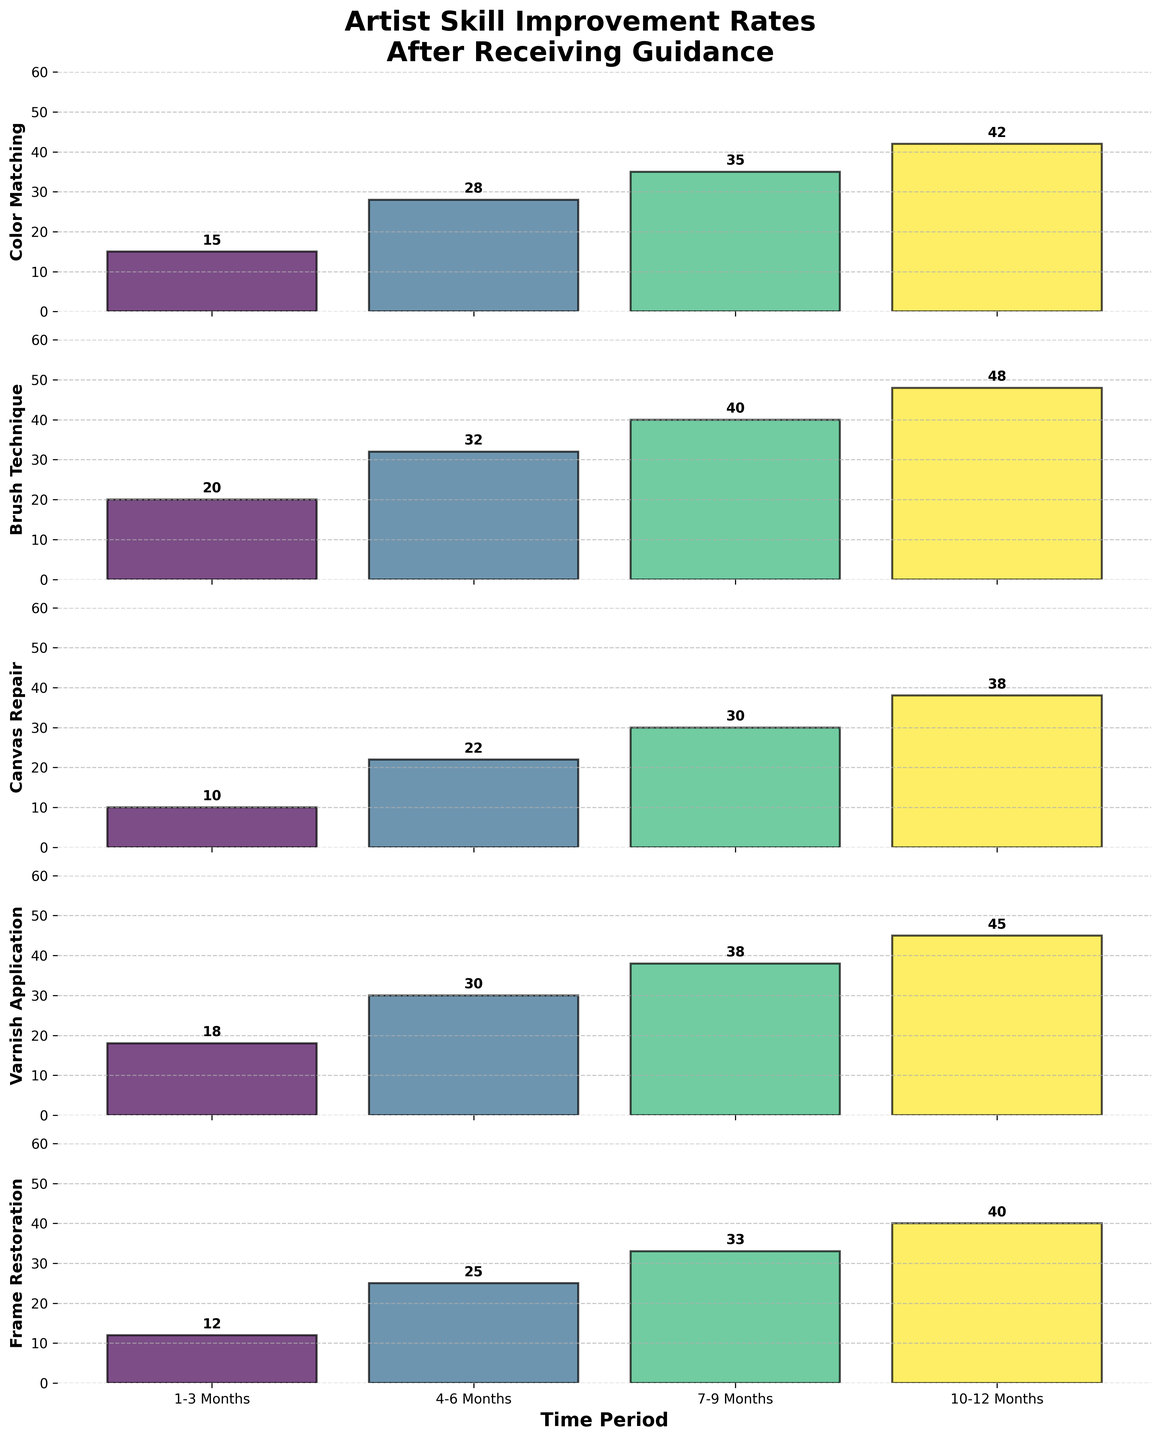Which technique shows the highest improvement rate after 10-12 months? The improvement rate for each technique at the 10-12 months period can be directly observed from the top bar of each subplot. Varnish Application shows the highest improvement rate of 45.
Answer: Varnish Application What is the overall trend for Color Matching over the four periods? Looking at the bars for Color Matching, the heights increase progressively from 15, 28, 35 to 42, indicating a consistent improvement in artist skills over time.
Answer: Increasing Compare the improvement rates for Brush Technique and Canvas Repair at 7-9 months. The subplot for Brush Technique shows a value of 40 at 7-9 months, while Canvas Repair shows a value of 30 at the same period. Brush Technique has a higher improvement rate (40).
Answer: Brush Technique What is the average improvement rate for Frame Restoration across all periods? The values for Frame Restoration at the given periods are 12, 25, 33, and 40. Adding these values and dividing by 4 gives (12+25+33+40)/4 = 27.5.
Answer: 27.5 Which technique has the lowest initial (1-3 months) improvement rate? By looking at the first bars of each subplot, Canvas Repair has the lowest initial improvement rate of 10.
Answer: Canvas Repair How much more improvement does Color Matching show at 10-12 months compared to 4-6 months? The improvement rates for Color Matching at 10-12 months and 4-6 months are 42 and 28 respectively. The difference is 42 - 28 = 14.
Answer: 14 Which technique shows the most significant improvement from 1-3 months to 10-12 months? Calculating the difference between the 10-12 months and 1-3 months columns for each technique:
- Color Matching: 42 - 15 = 27
- Brush Technique: 48 - 20 = 28
- Canvas Repair: 38 - 10 = 28
- Varnish Application: 45 - 18 = 27
- Frame Restoration: 40 - 12 = 28
Brush Technique, Canvas Repair, and Frame Restoration all show the highest improvement of 28.
Answer: Brush Technique, Canvas Repair, Frame Restoration What is the total improvement rate for Varnish Application across all periods? Summing the values for Varnish Application across the 4 periods: 18 + 30 + 38 + 45 gives a total of 131.
Answer: 131 